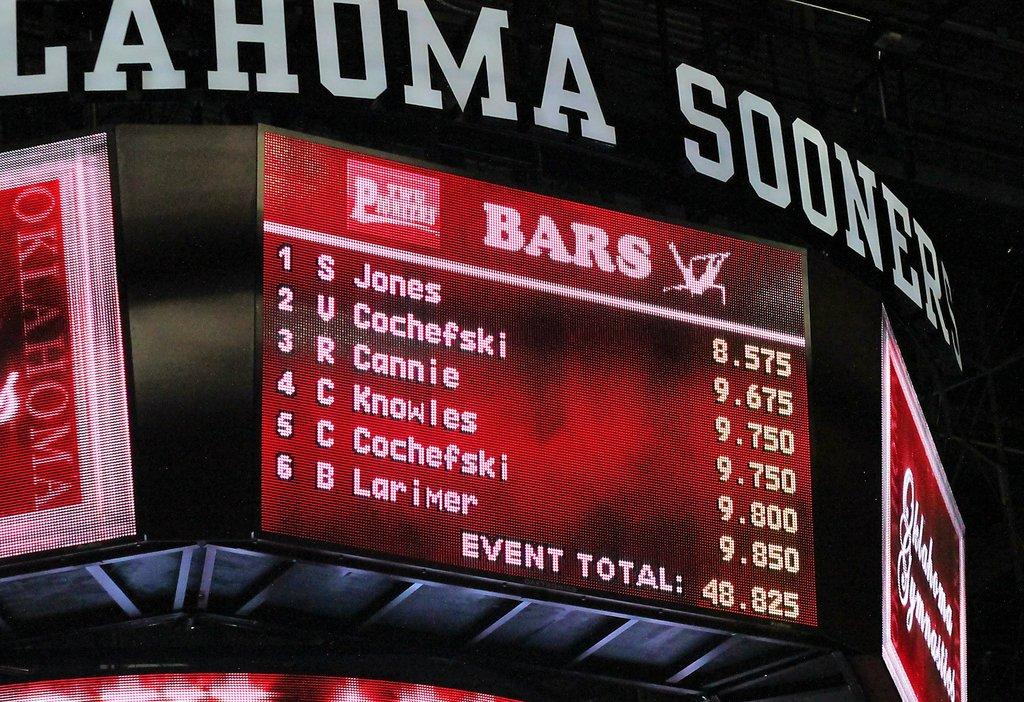Provide a one-sentence caption for the provided image. A score sheet on the Jumbo tron for the Ohlahoma Sooners. 